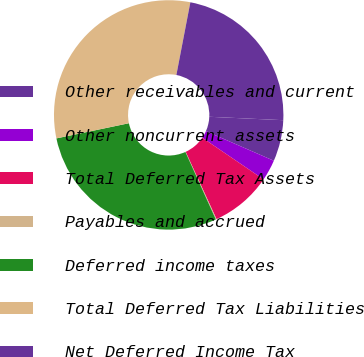<chart> <loc_0><loc_0><loc_500><loc_500><pie_chart><fcel>Other receivables and current<fcel>Other noncurrent assets<fcel>Total Deferred Tax Assets<fcel>Payables and accrued<fcel>Deferred income taxes<fcel>Total Deferred Tax Liabilities<fcel>Net Deferred Income Tax<nl><fcel>5.81%<fcel>2.96%<fcel>8.65%<fcel>0.11%<fcel>28.46%<fcel>31.31%<fcel>22.71%<nl></chart> 